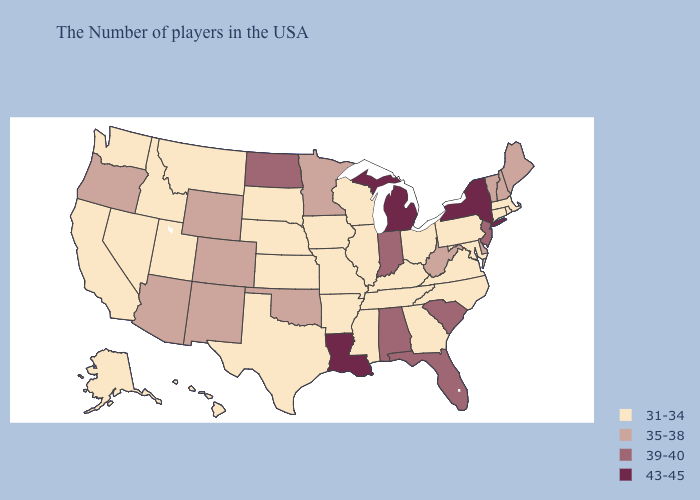What is the value of Nevada?
Write a very short answer. 31-34. Name the states that have a value in the range 39-40?
Give a very brief answer. New Jersey, South Carolina, Florida, Indiana, Alabama, North Dakota. What is the highest value in the USA?
Quick response, please. 43-45. Among the states that border Mississippi , does Arkansas have the highest value?
Quick response, please. No. What is the value of South Dakota?
Give a very brief answer. 31-34. Does Alabama have the lowest value in the USA?
Answer briefly. No. Among the states that border Delaware , which have the lowest value?
Be succinct. Maryland, Pennsylvania. Name the states that have a value in the range 35-38?
Concise answer only. Maine, New Hampshire, Vermont, Delaware, West Virginia, Minnesota, Oklahoma, Wyoming, Colorado, New Mexico, Arizona, Oregon. What is the value of Tennessee?
Quick response, please. 31-34. What is the lowest value in the South?
Concise answer only. 31-34. What is the value of California?
Quick response, please. 31-34. Name the states that have a value in the range 39-40?
Answer briefly. New Jersey, South Carolina, Florida, Indiana, Alabama, North Dakota. What is the value of Virginia?
Concise answer only. 31-34. Does the first symbol in the legend represent the smallest category?
Write a very short answer. Yes. Which states hav the highest value in the Northeast?
Concise answer only. New York. 